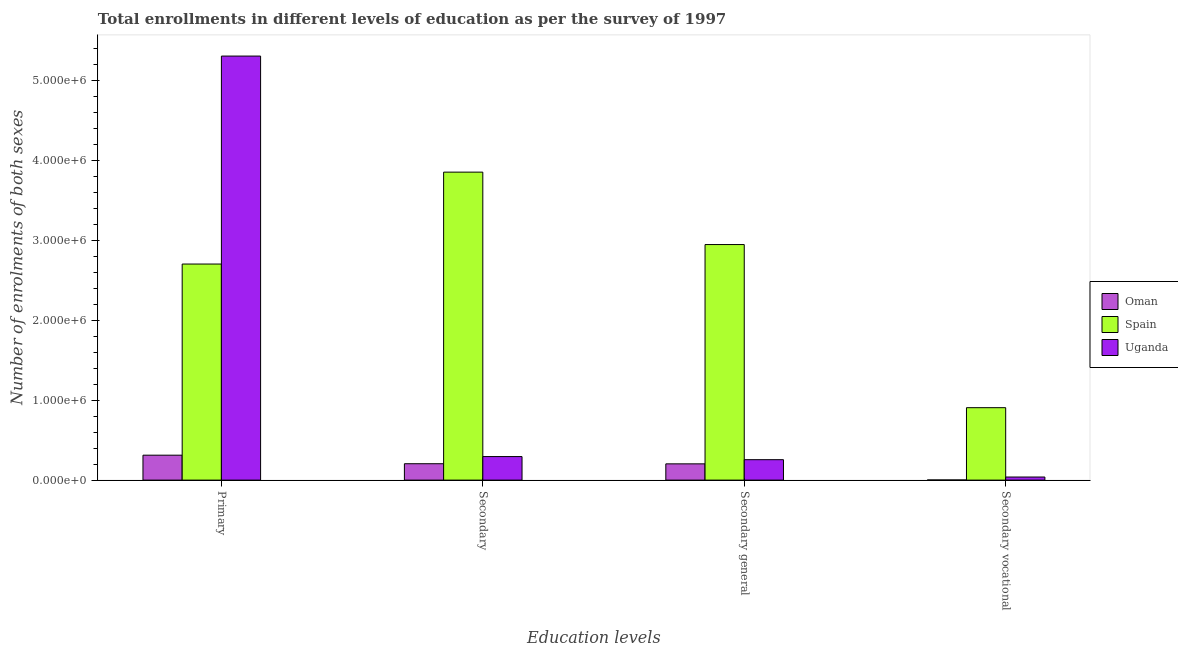How many different coloured bars are there?
Offer a terse response. 3. How many groups of bars are there?
Offer a terse response. 4. What is the label of the 2nd group of bars from the left?
Provide a succinct answer. Secondary. What is the number of enrolments in secondary vocational education in Uganda?
Your answer should be very brief. 3.87e+04. Across all countries, what is the maximum number of enrolments in secondary vocational education?
Your answer should be compact. 9.06e+05. Across all countries, what is the minimum number of enrolments in secondary general education?
Your response must be concise. 2.03e+05. In which country was the number of enrolments in secondary general education minimum?
Offer a terse response. Oman. What is the total number of enrolments in secondary education in the graph?
Keep it short and to the point. 4.35e+06. What is the difference between the number of enrolments in secondary education in Uganda and that in Oman?
Give a very brief answer. 8.94e+04. What is the difference between the number of enrolments in secondary vocational education in Spain and the number of enrolments in primary education in Uganda?
Your answer should be compact. -4.40e+06. What is the average number of enrolments in secondary general education per country?
Ensure brevity in your answer.  1.14e+06. What is the difference between the number of enrolments in secondary vocational education and number of enrolments in secondary general education in Uganda?
Your answer should be compact. -2.17e+05. What is the ratio of the number of enrolments in secondary general education in Uganda to that in Oman?
Offer a very short reply. 1.26. What is the difference between the highest and the second highest number of enrolments in secondary education?
Keep it short and to the point. 3.56e+06. What is the difference between the highest and the lowest number of enrolments in secondary vocational education?
Your answer should be compact. 9.04e+05. Is it the case that in every country, the sum of the number of enrolments in secondary general education and number of enrolments in secondary vocational education is greater than the sum of number of enrolments in secondary education and number of enrolments in primary education?
Your response must be concise. No. What does the 1st bar from the left in Secondary vocational represents?
Give a very brief answer. Oman. What does the 3rd bar from the right in Secondary general represents?
Keep it short and to the point. Oman. How many bars are there?
Keep it short and to the point. 12. How many countries are there in the graph?
Your answer should be compact. 3. What is the difference between two consecutive major ticks on the Y-axis?
Give a very brief answer. 1.00e+06. Are the values on the major ticks of Y-axis written in scientific E-notation?
Provide a short and direct response. Yes. Does the graph contain grids?
Ensure brevity in your answer.  No. How many legend labels are there?
Your answer should be very brief. 3. What is the title of the graph?
Keep it short and to the point. Total enrollments in different levels of education as per the survey of 1997. What is the label or title of the X-axis?
Offer a terse response. Education levels. What is the label or title of the Y-axis?
Give a very brief answer. Number of enrolments of both sexes. What is the Number of enrolments of both sexes in Oman in Primary?
Offer a very short reply. 3.12e+05. What is the Number of enrolments of both sexes of Spain in Primary?
Provide a short and direct response. 2.70e+06. What is the Number of enrolments of both sexes of Uganda in Primary?
Give a very brief answer. 5.30e+06. What is the Number of enrolments of both sexes in Oman in Secondary?
Your response must be concise. 2.05e+05. What is the Number of enrolments of both sexes in Spain in Secondary?
Make the answer very short. 3.85e+06. What is the Number of enrolments of both sexes in Uganda in Secondary?
Give a very brief answer. 2.94e+05. What is the Number of enrolments of both sexes of Oman in Secondary general?
Your answer should be very brief. 2.03e+05. What is the Number of enrolments of both sexes of Spain in Secondary general?
Keep it short and to the point. 2.95e+06. What is the Number of enrolments of both sexes of Uganda in Secondary general?
Provide a succinct answer. 2.56e+05. What is the Number of enrolments of both sexes in Oman in Secondary vocational?
Ensure brevity in your answer.  1700. What is the Number of enrolments of both sexes in Spain in Secondary vocational?
Ensure brevity in your answer.  9.06e+05. What is the Number of enrolments of both sexes in Uganda in Secondary vocational?
Offer a terse response. 3.87e+04. Across all Education levels, what is the maximum Number of enrolments of both sexes in Oman?
Ensure brevity in your answer.  3.12e+05. Across all Education levels, what is the maximum Number of enrolments of both sexes of Spain?
Offer a very short reply. 3.85e+06. Across all Education levels, what is the maximum Number of enrolments of both sexes in Uganda?
Offer a terse response. 5.30e+06. Across all Education levels, what is the minimum Number of enrolments of both sexes of Oman?
Provide a short and direct response. 1700. Across all Education levels, what is the minimum Number of enrolments of both sexes of Spain?
Offer a terse response. 9.06e+05. Across all Education levels, what is the minimum Number of enrolments of both sexes of Uganda?
Offer a terse response. 3.87e+04. What is the total Number of enrolments of both sexes in Oman in the graph?
Make the answer very short. 7.22e+05. What is the total Number of enrolments of both sexes in Spain in the graph?
Your answer should be very brief. 1.04e+07. What is the total Number of enrolments of both sexes of Uganda in the graph?
Your answer should be compact. 5.89e+06. What is the difference between the Number of enrolments of both sexes in Oman in Primary and that in Secondary?
Keep it short and to the point. 1.07e+05. What is the difference between the Number of enrolments of both sexes in Spain in Primary and that in Secondary?
Make the answer very short. -1.15e+06. What is the difference between the Number of enrolments of both sexes in Uganda in Primary and that in Secondary?
Ensure brevity in your answer.  5.01e+06. What is the difference between the Number of enrolments of both sexes of Oman in Primary and that in Secondary general?
Make the answer very short. 1.09e+05. What is the difference between the Number of enrolments of both sexes in Spain in Primary and that in Secondary general?
Make the answer very short. -2.44e+05. What is the difference between the Number of enrolments of both sexes of Uganda in Primary and that in Secondary general?
Offer a very short reply. 5.05e+06. What is the difference between the Number of enrolments of both sexes in Oman in Primary and that in Secondary vocational?
Provide a short and direct response. 3.10e+05. What is the difference between the Number of enrolments of both sexes of Spain in Primary and that in Secondary vocational?
Make the answer very short. 1.80e+06. What is the difference between the Number of enrolments of both sexes in Uganda in Primary and that in Secondary vocational?
Give a very brief answer. 5.26e+06. What is the difference between the Number of enrolments of both sexes in Oman in Secondary and that in Secondary general?
Your response must be concise. 1700. What is the difference between the Number of enrolments of both sexes of Spain in Secondary and that in Secondary general?
Your answer should be very brief. 9.06e+05. What is the difference between the Number of enrolments of both sexes in Uganda in Secondary and that in Secondary general?
Your answer should be compact. 3.87e+04. What is the difference between the Number of enrolments of both sexes of Oman in Secondary and that in Secondary vocational?
Your answer should be very brief. 2.03e+05. What is the difference between the Number of enrolments of both sexes in Spain in Secondary and that in Secondary vocational?
Offer a very short reply. 2.95e+06. What is the difference between the Number of enrolments of both sexes in Uganda in Secondary and that in Secondary vocational?
Give a very brief answer. 2.56e+05. What is the difference between the Number of enrolments of both sexes in Oman in Secondary general and that in Secondary vocational?
Your answer should be compact. 2.02e+05. What is the difference between the Number of enrolments of both sexes in Spain in Secondary general and that in Secondary vocational?
Keep it short and to the point. 2.04e+06. What is the difference between the Number of enrolments of both sexes in Uganda in Secondary general and that in Secondary vocational?
Offer a terse response. 2.17e+05. What is the difference between the Number of enrolments of both sexes in Oman in Primary and the Number of enrolments of both sexes in Spain in Secondary?
Your answer should be compact. -3.54e+06. What is the difference between the Number of enrolments of both sexes in Oman in Primary and the Number of enrolments of both sexes in Uganda in Secondary?
Provide a succinct answer. 1.75e+04. What is the difference between the Number of enrolments of both sexes in Spain in Primary and the Number of enrolments of both sexes in Uganda in Secondary?
Offer a very short reply. 2.41e+06. What is the difference between the Number of enrolments of both sexes of Oman in Primary and the Number of enrolments of both sexes of Spain in Secondary general?
Ensure brevity in your answer.  -2.63e+06. What is the difference between the Number of enrolments of both sexes of Oman in Primary and the Number of enrolments of both sexes of Uganda in Secondary general?
Your response must be concise. 5.63e+04. What is the difference between the Number of enrolments of both sexes of Spain in Primary and the Number of enrolments of both sexes of Uganda in Secondary general?
Your response must be concise. 2.45e+06. What is the difference between the Number of enrolments of both sexes of Oman in Primary and the Number of enrolments of both sexes of Spain in Secondary vocational?
Provide a succinct answer. -5.94e+05. What is the difference between the Number of enrolments of both sexes in Oman in Primary and the Number of enrolments of both sexes in Uganda in Secondary vocational?
Provide a short and direct response. 2.73e+05. What is the difference between the Number of enrolments of both sexes of Spain in Primary and the Number of enrolments of both sexes of Uganda in Secondary vocational?
Make the answer very short. 2.66e+06. What is the difference between the Number of enrolments of both sexes of Oman in Secondary and the Number of enrolments of both sexes of Spain in Secondary general?
Ensure brevity in your answer.  -2.74e+06. What is the difference between the Number of enrolments of both sexes in Oman in Secondary and the Number of enrolments of both sexes in Uganda in Secondary general?
Give a very brief answer. -5.06e+04. What is the difference between the Number of enrolments of both sexes of Spain in Secondary and the Number of enrolments of both sexes of Uganda in Secondary general?
Your answer should be very brief. 3.60e+06. What is the difference between the Number of enrolments of both sexes of Oman in Secondary and the Number of enrolments of both sexes of Spain in Secondary vocational?
Make the answer very short. -7.01e+05. What is the difference between the Number of enrolments of both sexes in Oman in Secondary and the Number of enrolments of both sexes in Uganda in Secondary vocational?
Offer a terse response. 1.66e+05. What is the difference between the Number of enrolments of both sexes in Spain in Secondary and the Number of enrolments of both sexes in Uganda in Secondary vocational?
Offer a very short reply. 3.81e+06. What is the difference between the Number of enrolments of both sexes in Oman in Secondary general and the Number of enrolments of both sexes in Spain in Secondary vocational?
Provide a succinct answer. -7.03e+05. What is the difference between the Number of enrolments of both sexes in Oman in Secondary general and the Number of enrolments of both sexes in Uganda in Secondary vocational?
Provide a succinct answer. 1.65e+05. What is the difference between the Number of enrolments of both sexes of Spain in Secondary general and the Number of enrolments of both sexes of Uganda in Secondary vocational?
Provide a short and direct response. 2.91e+06. What is the average Number of enrolments of both sexes in Oman per Education levels?
Provide a short and direct response. 1.81e+05. What is the average Number of enrolments of both sexes in Spain per Education levels?
Your response must be concise. 2.60e+06. What is the average Number of enrolments of both sexes of Uganda per Education levels?
Your response must be concise. 1.47e+06. What is the difference between the Number of enrolments of both sexes of Oman and Number of enrolments of both sexes of Spain in Primary?
Provide a succinct answer. -2.39e+06. What is the difference between the Number of enrolments of both sexes of Oman and Number of enrolments of both sexes of Uganda in Primary?
Your answer should be compact. -4.99e+06. What is the difference between the Number of enrolments of both sexes in Spain and Number of enrolments of both sexes in Uganda in Primary?
Make the answer very short. -2.60e+06. What is the difference between the Number of enrolments of both sexes in Oman and Number of enrolments of both sexes in Spain in Secondary?
Offer a terse response. -3.65e+06. What is the difference between the Number of enrolments of both sexes of Oman and Number of enrolments of both sexes of Uganda in Secondary?
Ensure brevity in your answer.  -8.94e+04. What is the difference between the Number of enrolments of both sexes of Spain and Number of enrolments of both sexes of Uganda in Secondary?
Keep it short and to the point. 3.56e+06. What is the difference between the Number of enrolments of both sexes in Oman and Number of enrolments of both sexes in Spain in Secondary general?
Make the answer very short. -2.74e+06. What is the difference between the Number of enrolments of both sexes in Oman and Number of enrolments of both sexes in Uganda in Secondary general?
Offer a terse response. -5.23e+04. What is the difference between the Number of enrolments of both sexes in Spain and Number of enrolments of both sexes in Uganda in Secondary general?
Keep it short and to the point. 2.69e+06. What is the difference between the Number of enrolments of both sexes in Oman and Number of enrolments of both sexes in Spain in Secondary vocational?
Give a very brief answer. -9.04e+05. What is the difference between the Number of enrolments of both sexes of Oman and Number of enrolments of both sexes of Uganda in Secondary vocational?
Your answer should be compact. -3.70e+04. What is the difference between the Number of enrolments of both sexes of Spain and Number of enrolments of both sexes of Uganda in Secondary vocational?
Your answer should be very brief. 8.67e+05. What is the ratio of the Number of enrolments of both sexes of Oman in Primary to that in Secondary?
Give a very brief answer. 1.52. What is the ratio of the Number of enrolments of both sexes in Spain in Primary to that in Secondary?
Provide a succinct answer. 0.7. What is the ratio of the Number of enrolments of both sexes of Uganda in Primary to that in Secondary?
Provide a short and direct response. 18.01. What is the ratio of the Number of enrolments of both sexes of Oman in Primary to that in Secondary general?
Your answer should be very brief. 1.53. What is the ratio of the Number of enrolments of both sexes in Spain in Primary to that in Secondary general?
Provide a succinct answer. 0.92. What is the ratio of the Number of enrolments of both sexes of Uganda in Primary to that in Secondary general?
Make the answer very short. 20.74. What is the ratio of the Number of enrolments of both sexes in Oman in Primary to that in Secondary vocational?
Give a very brief answer. 183.5. What is the ratio of the Number of enrolments of both sexes in Spain in Primary to that in Secondary vocational?
Make the answer very short. 2.98. What is the ratio of the Number of enrolments of both sexes of Uganda in Primary to that in Secondary vocational?
Your answer should be compact. 136.89. What is the ratio of the Number of enrolments of both sexes in Oman in Secondary to that in Secondary general?
Keep it short and to the point. 1.01. What is the ratio of the Number of enrolments of both sexes in Spain in Secondary to that in Secondary general?
Offer a very short reply. 1.31. What is the ratio of the Number of enrolments of both sexes in Uganda in Secondary to that in Secondary general?
Provide a short and direct response. 1.15. What is the ratio of the Number of enrolments of both sexes in Oman in Secondary to that in Secondary vocational?
Provide a succinct answer. 120.62. What is the ratio of the Number of enrolments of both sexes in Spain in Secondary to that in Secondary vocational?
Give a very brief answer. 4.25. What is the ratio of the Number of enrolments of both sexes in Uganda in Secondary to that in Secondary vocational?
Make the answer very short. 7.6. What is the ratio of the Number of enrolments of both sexes in Oman in Secondary general to that in Secondary vocational?
Make the answer very short. 119.62. What is the ratio of the Number of enrolments of both sexes in Spain in Secondary general to that in Secondary vocational?
Give a very brief answer. 3.25. What is the ratio of the Number of enrolments of both sexes of Uganda in Secondary general to that in Secondary vocational?
Your answer should be compact. 6.6. What is the difference between the highest and the second highest Number of enrolments of both sexes of Oman?
Provide a succinct answer. 1.07e+05. What is the difference between the highest and the second highest Number of enrolments of both sexes of Spain?
Your response must be concise. 9.06e+05. What is the difference between the highest and the second highest Number of enrolments of both sexes in Uganda?
Make the answer very short. 5.01e+06. What is the difference between the highest and the lowest Number of enrolments of both sexes of Oman?
Provide a succinct answer. 3.10e+05. What is the difference between the highest and the lowest Number of enrolments of both sexes of Spain?
Give a very brief answer. 2.95e+06. What is the difference between the highest and the lowest Number of enrolments of both sexes of Uganda?
Provide a succinct answer. 5.26e+06. 